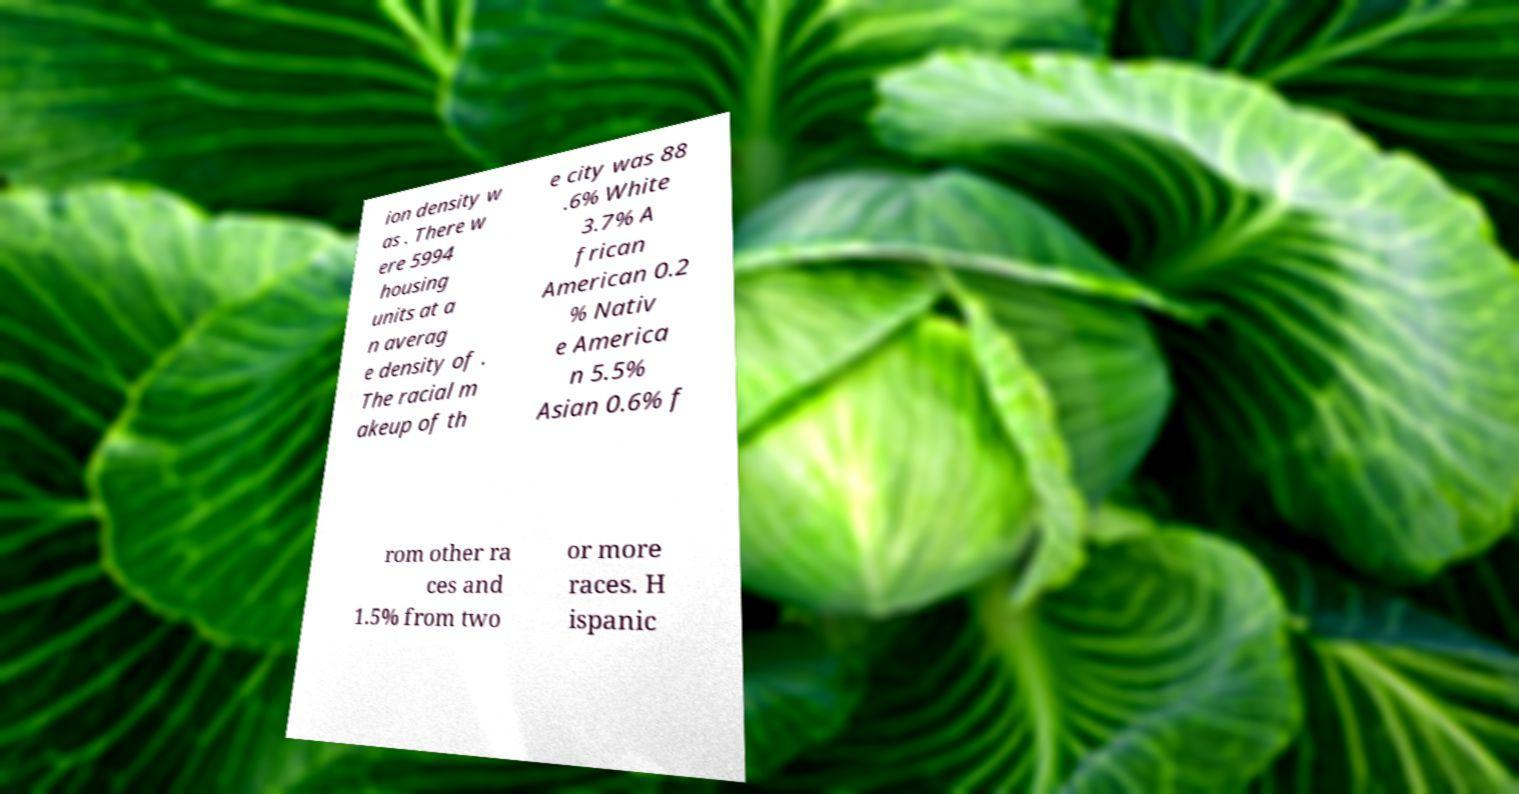Can you accurately transcribe the text from the provided image for me? ion density w as . There w ere 5994 housing units at a n averag e density of . The racial m akeup of th e city was 88 .6% White 3.7% A frican American 0.2 % Nativ e America n 5.5% Asian 0.6% f rom other ra ces and 1.5% from two or more races. H ispanic 